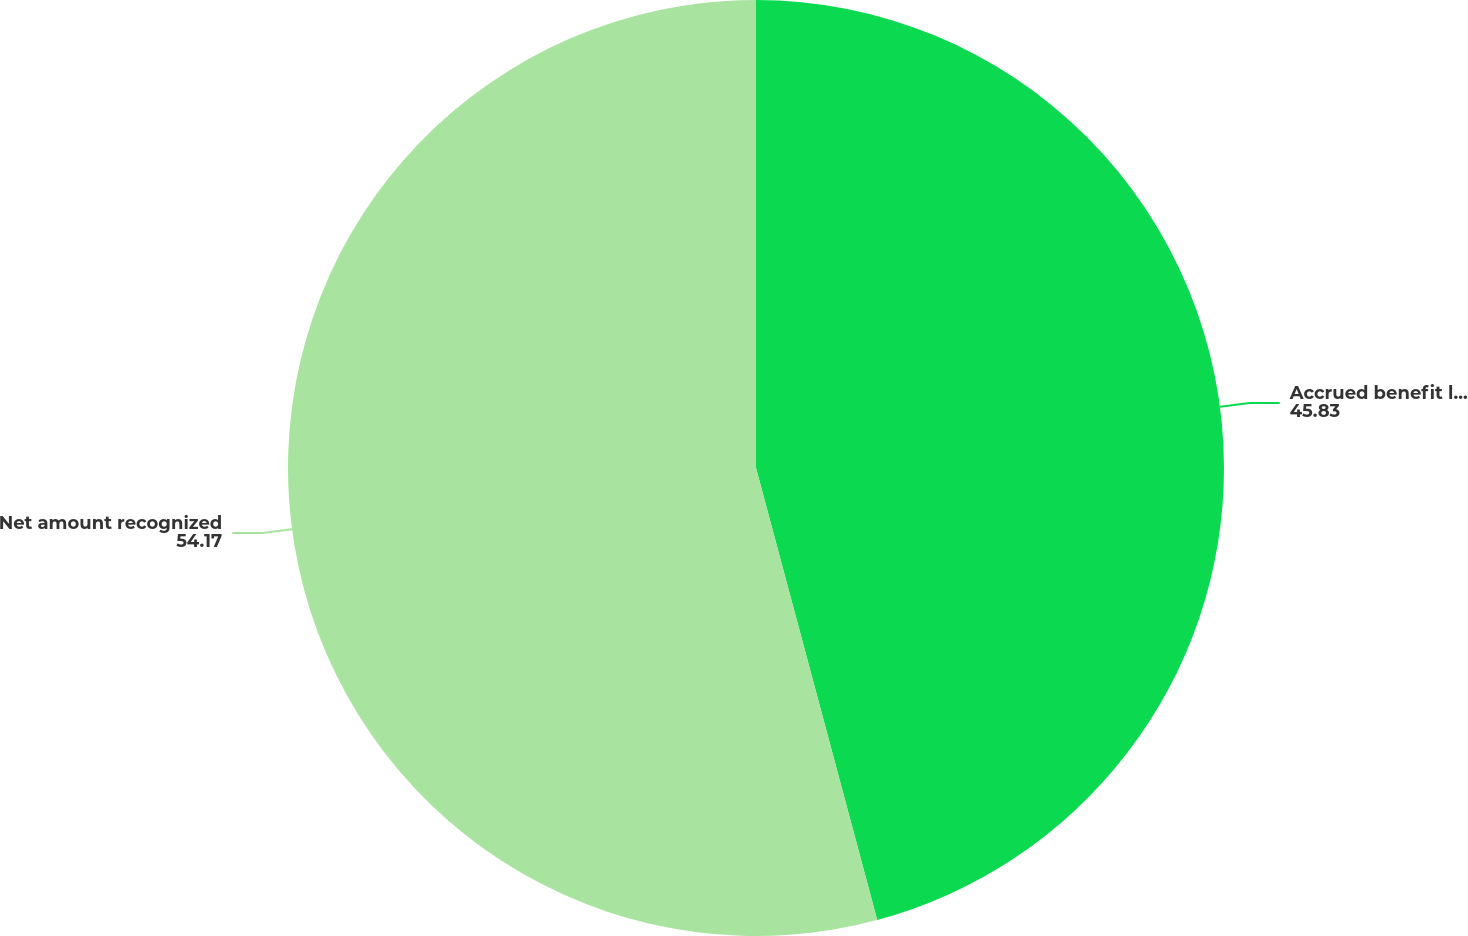Convert chart to OTSL. <chart><loc_0><loc_0><loc_500><loc_500><pie_chart><fcel>Accrued benefit liability<fcel>Net amount recognized<nl><fcel>45.83%<fcel>54.17%<nl></chart> 